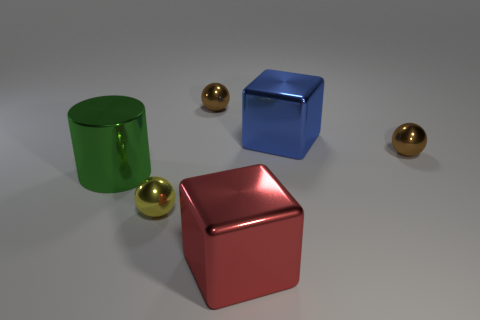Add 3 cyan cylinders. How many objects exist? 9 Subtract all cylinders. How many objects are left? 5 Subtract all tiny red balls. Subtract all red shiny objects. How many objects are left? 5 Add 2 metallic cylinders. How many metallic cylinders are left? 3 Add 2 yellow matte things. How many yellow matte things exist? 2 Subtract 0 purple balls. How many objects are left? 6 